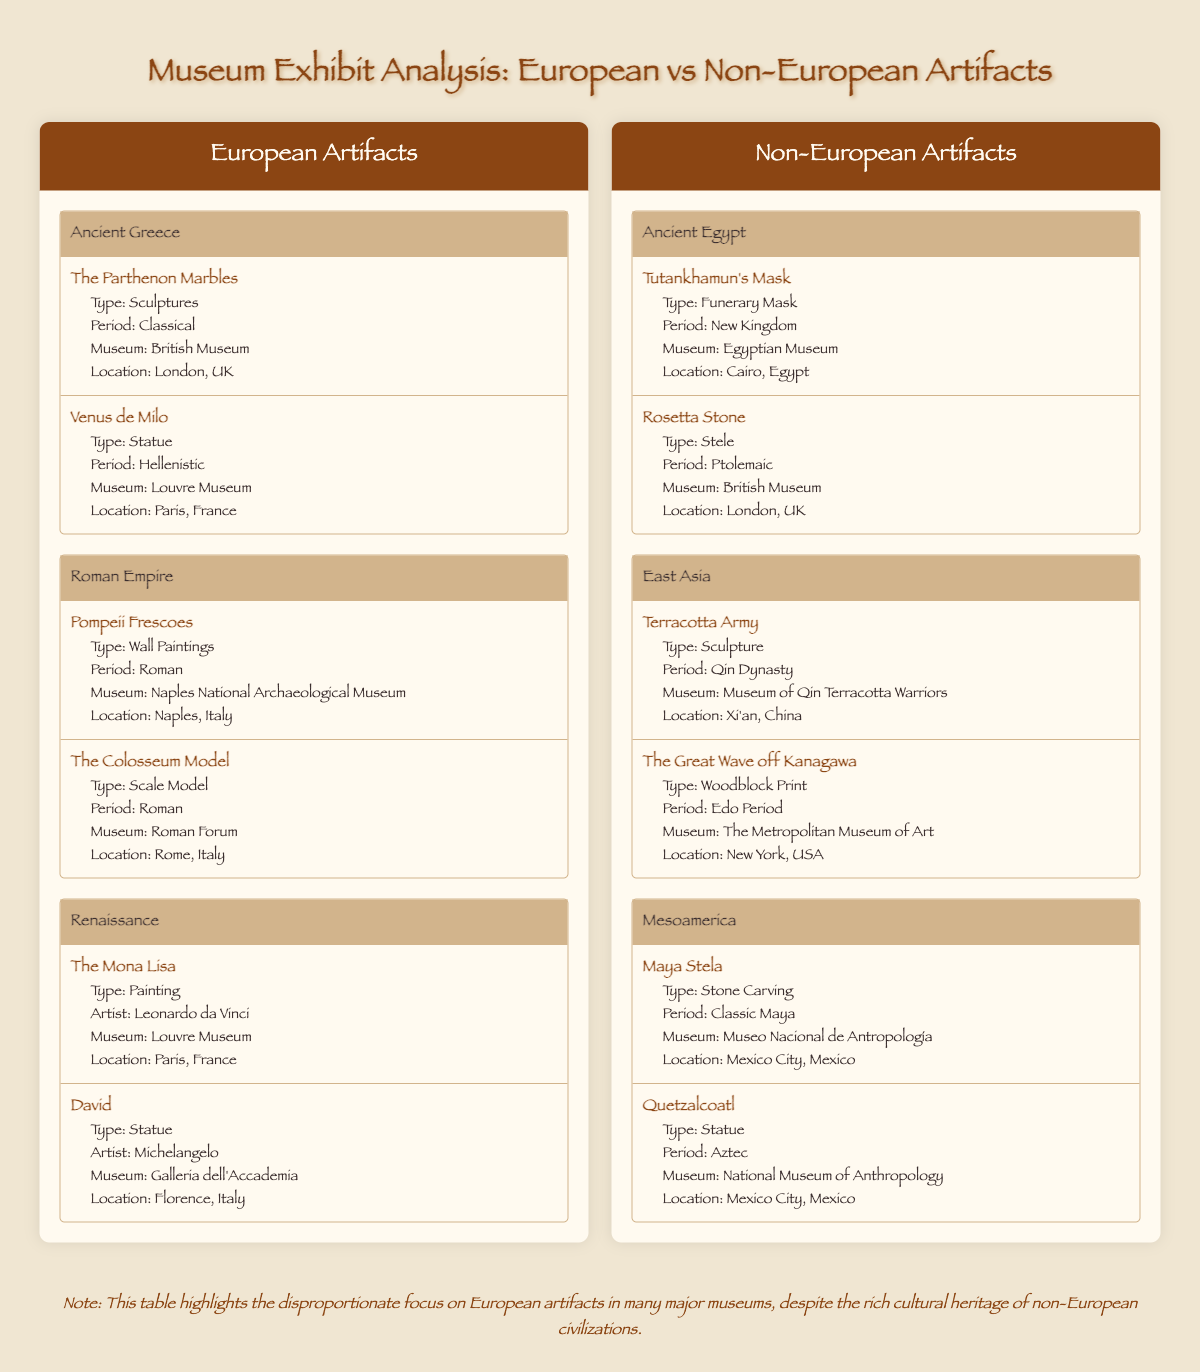What types of artifacts are listed under the Ancient Egypt category? The Ancient Egypt category contains two artifacts: Tutankhamun's Mask, which is a funerary mask, and the Rosetta Stone, which is a stele.
Answer: Funerary Mask and Stele How many artifacts are categorized under Non-European Artifacts? There are six artifacts listed under Non-European Artifacts: two from Ancient Egypt, two from East Asia, and two from Mesoamerica. Summing them gives a total of 6 artifacts.
Answer: 6 Is the Venus de Milo located in the British Museum? The Venus de Milo is located in the Louvre Museum in Paris, France, not in the British Museum.
Answer: No Which museum houses the Terracotta Army artifact? The Terracotta Army is housed in the Museum of Qin Terracotta Warriors located in Xi'an, China.
Answer: Museum of Qin Terracotta Warriors What is the total number of artifacts in the European Artifacts section? The European Artifacts section includes six artifacts: two from Ancient Greece, two from the Roman Empire, and two from the Renaissance. Adding these gives a total of 6 artifacts in the section.
Answer: 6 Do any of the Non-European artifacts have a location in London? Yes, both Tutankhamun's Mask and the Rosetta Stone are mentioned in the Non-European section, with the Rosetta Stone specifically located in London, UK.
Answer: Yes Which category has the most artifacts listed in the table? Both the European Artifacts and the Non-European Artifacts sections contain three categories each, with two artifacts listed in each category. Therefore, all categories have an equal amount of artifacts.
Answer: Equal What is the period of the artifact "David"? The statue "David," created by the artist Michelangelo, is classified under the Renaissance period.
Answer: Renaissance Which region has more artifacts displayed in the table overall, European or Non-European? The European Artifacts section lists a total of six artifacts, while the Non-European Artifacts section also has six artifacts. Therefore, they are equal in terms of the number of displayed artifacts.
Answer: Equal 